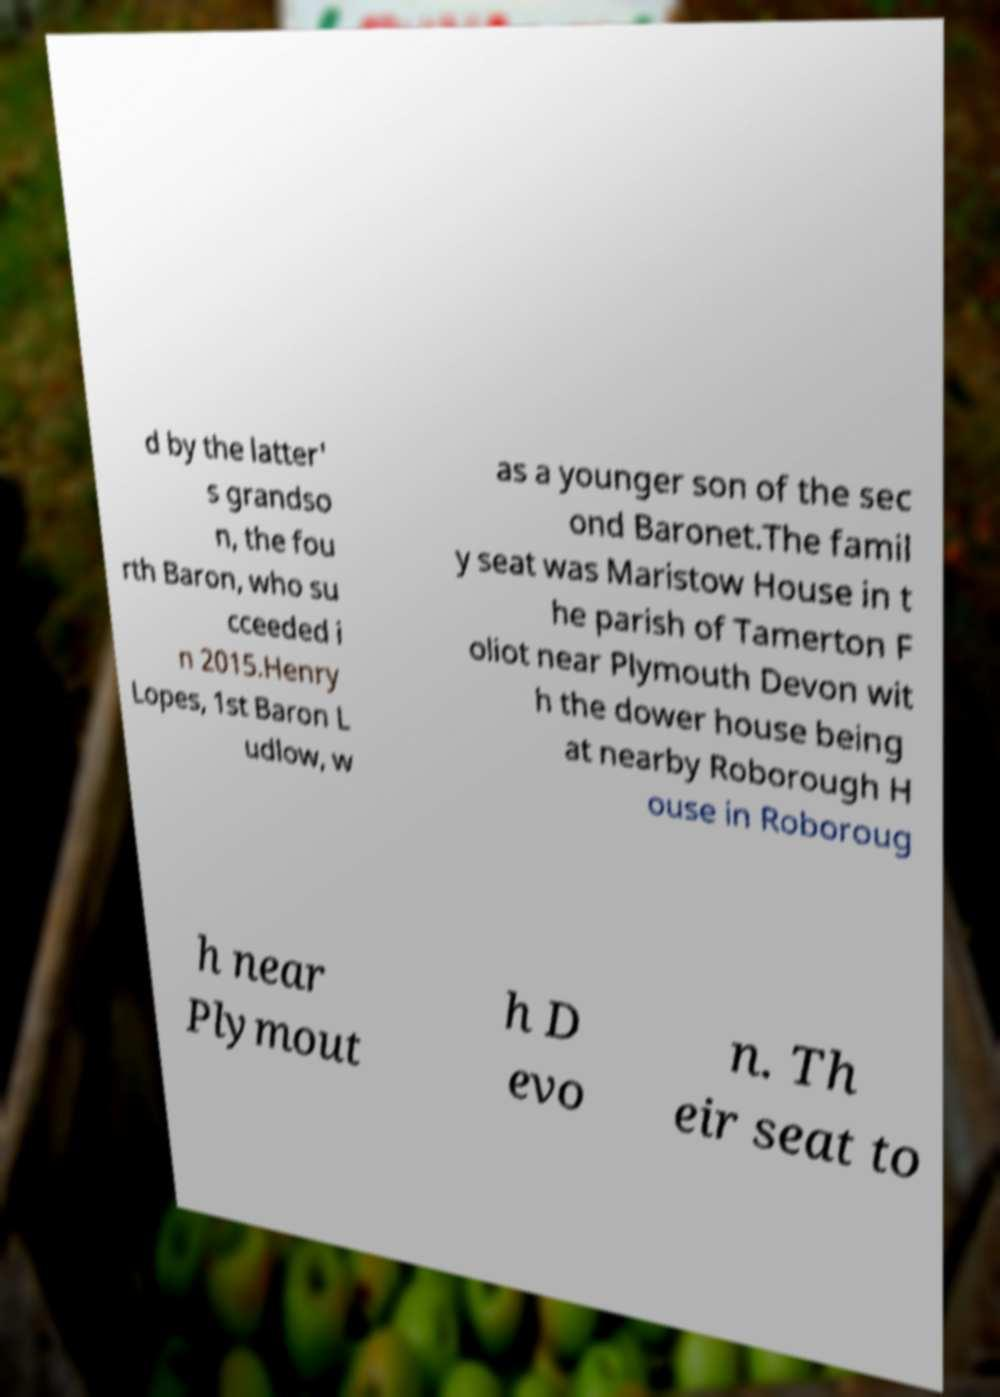Can you accurately transcribe the text from the provided image for me? d by the latter' s grandso n, the fou rth Baron, who su cceeded i n 2015.Henry Lopes, 1st Baron L udlow, w as a younger son of the sec ond Baronet.The famil y seat was Maristow House in t he parish of Tamerton F oliot near Plymouth Devon wit h the dower house being at nearby Roborough H ouse in Roboroug h near Plymout h D evo n. Th eir seat to 